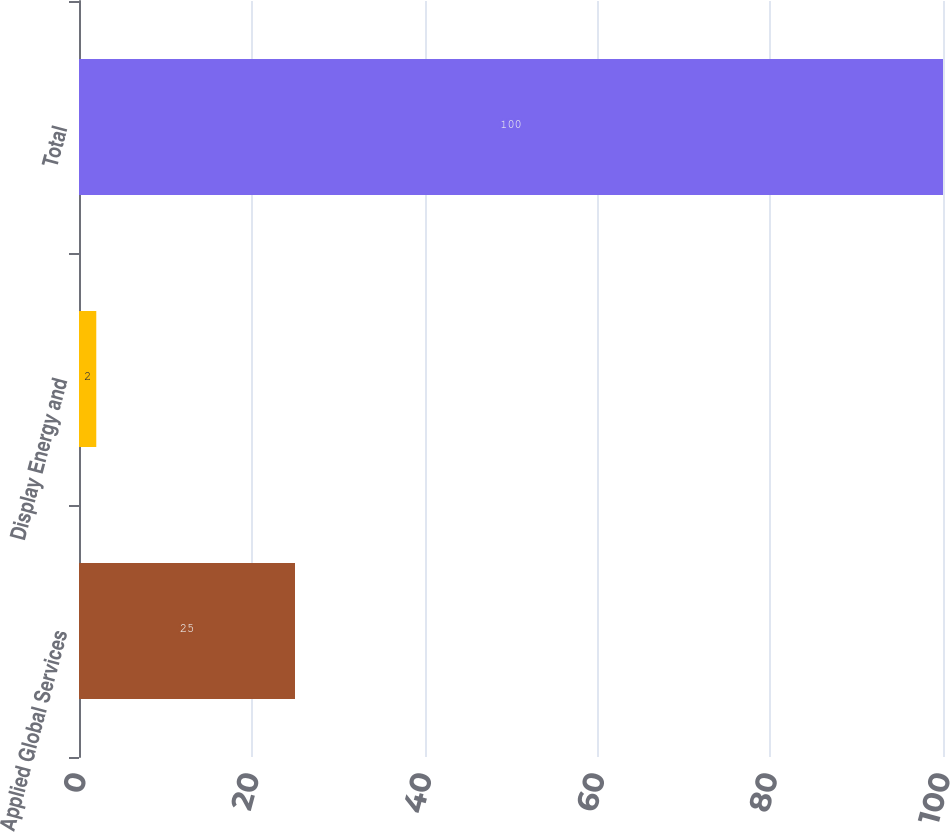<chart> <loc_0><loc_0><loc_500><loc_500><bar_chart><fcel>Applied Global Services<fcel>Display Energy and<fcel>Total<nl><fcel>25<fcel>2<fcel>100<nl></chart> 